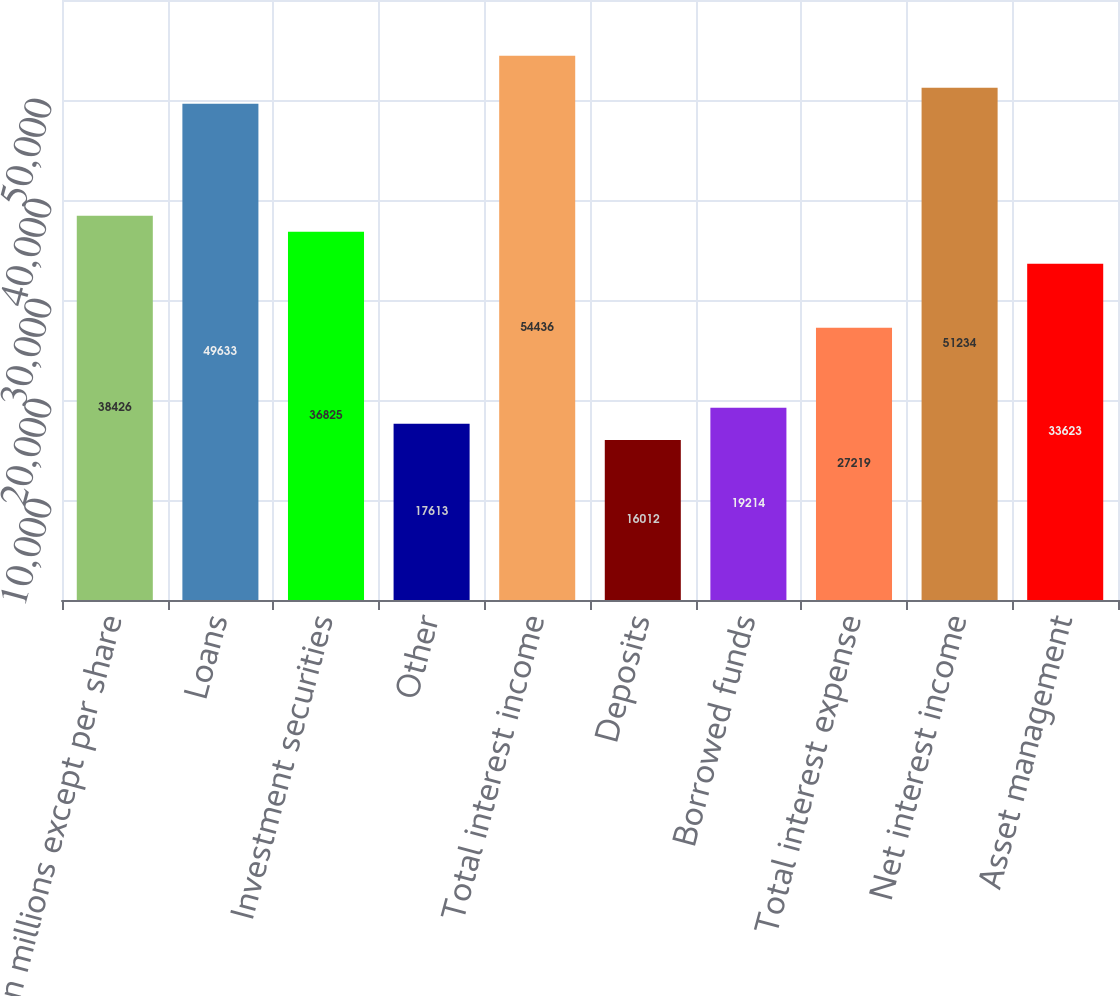Convert chart to OTSL. <chart><loc_0><loc_0><loc_500><loc_500><bar_chart><fcel>In millions except per share<fcel>Loans<fcel>Investment securities<fcel>Other<fcel>Total interest income<fcel>Deposits<fcel>Borrowed funds<fcel>Total interest expense<fcel>Net interest income<fcel>Asset management<nl><fcel>38426<fcel>49633<fcel>36825<fcel>17613<fcel>54436<fcel>16012<fcel>19214<fcel>27219<fcel>51234<fcel>33623<nl></chart> 